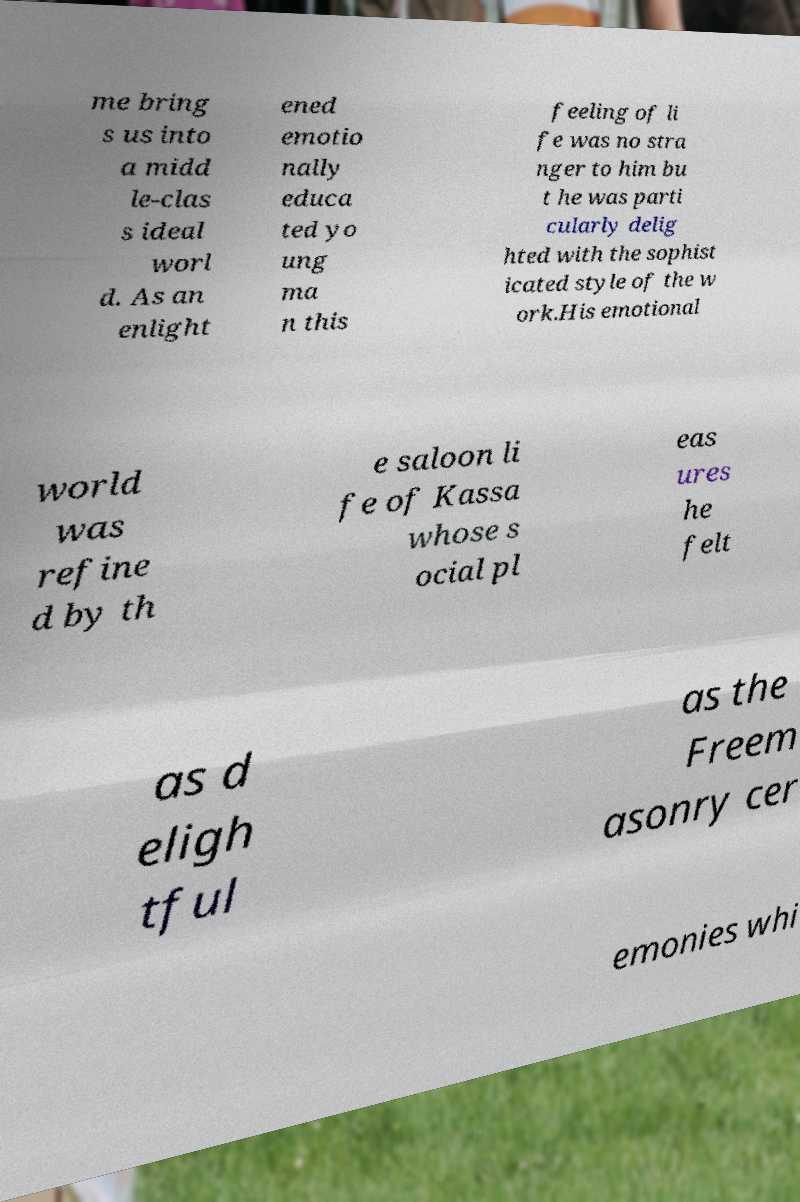Could you extract and type out the text from this image? me bring s us into a midd le-clas s ideal worl d. As an enlight ened emotio nally educa ted yo ung ma n this feeling of li fe was no stra nger to him bu t he was parti cularly delig hted with the sophist icated style of the w ork.His emotional world was refine d by th e saloon li fe of Kassa whose s ocial pl eas ures he felt as d eligh tful as the Freem asonry cer emonies whi 